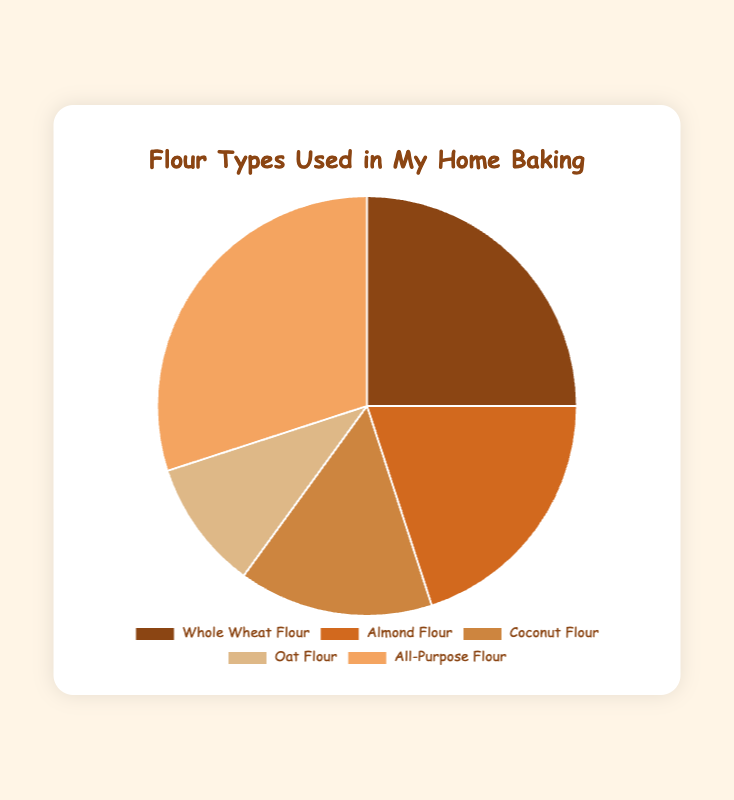What percentage of the total flour usage is Whole Wheat Flour and Almond Flour combined? We need to sum the percentages of Whole Wheat Flour (25%) and Almond Flour (20%). That adds up to 25% + 20% = 45%.
Answer: 45% Which type of flour is used the most? The figure shows that All-Purpose Flour has the highest percentage at 30%.
Answer: All-Purpose Flour How much more All-Purpose Flour is used compared to Coconut Flour? All-Purpose Flour is used 30% while Coconut Flour is used 15%. The difference is 30% - 15% = 15%.
Answer: 15% What is the ratio of Oat Flour usage to Almond Flour usage? Oat Flour is used 10% and Almond Flour is used 20%. The ratio is 10% / 20% = 1:2.
Answer: 1:2 Which flour types are represented by the warmest colors in the pie chart? Visually, warm colors often include shades like red, orange, and yellow. Colors associated with Whole Wheat Flour, Almond Flour, and Coconut Flour fall into these categories.
Answer: Whole Wheat Flour, Almond Flour, and Coconut Flour If another type of flour was added to the chart with a usage of 10%, what would be the new percentage for Oat Flour relative to the total? Assuming the current total is 100%, adding another flour type would change the total to 110%. Oat Flour's 10% would now be 10% of 110, which is (10/110) * 100 = ~9.09%.
Answer: ~9.09% Is the percentage usage of Coconut Flour less than that of Whole Wheat Flour and Almond Flour combined? Whole Wheat Flour is 25% and Almond Flour is 20%, so combined they are 45%, which is indeed greater than the 15% usage of Coconut Flour.
Answer: Yes Which flour type has the smallest proportion in the chart? The figure shows that Oat Flour has the smallest proportion at 10%.
Answer: Oat Flour What is the difference in flour usage between the highest and lowest used types? The highest usage is All-Purpose Flour at 30% and the lowest is Oat Flour at 10%. The difference is 30% - 10% = 20%.
Answer: 20% If you were to visually split the chart into two halves, which flour types would together make up approximately one half? All-Purpose Flour (30%) and Whole Wheat Flour (25%) add up to 55%, which is just over one half.
Answer: All-Purpose Flour and Whole Wheat Flour 